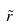Convert formula to latex. <formula><loc_0><loc_0><loc_500><loc_500>\tilde { r }</formula> 